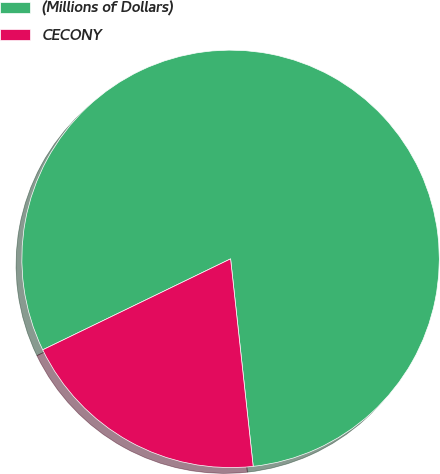Convert chart to OTSL. <chart><loc_0><loc_0><loc_500><loc_500><pie_chart><fcel>(Millions of Dollars)<fcel>CECONY<nl><fcel>80.45%<fcel>19.55%<nl></chart> 